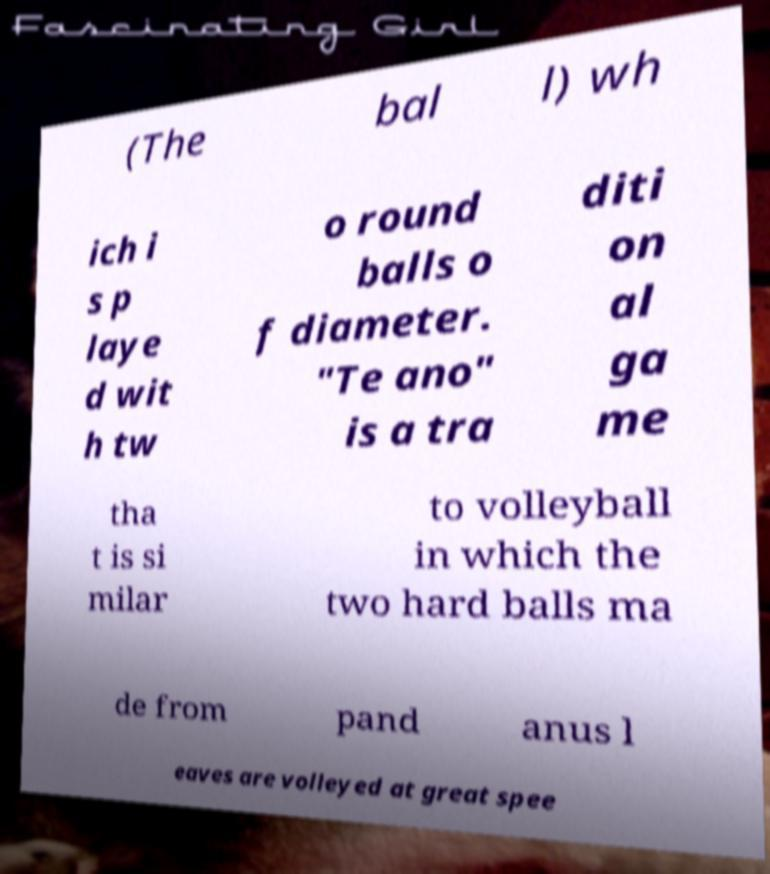Can you read and provide the text displayed in the image?This photo seems to have some interesting text. Can you extract and type it out for me? (The bal l) wh ich i s p laye d wit h tw o round balls o f diameter. "Te ano" is a tra diti on al ga me tha t is si milar to volleyball in which the two hard balls ma de from pand anus l eaves are volleyed at great spee 